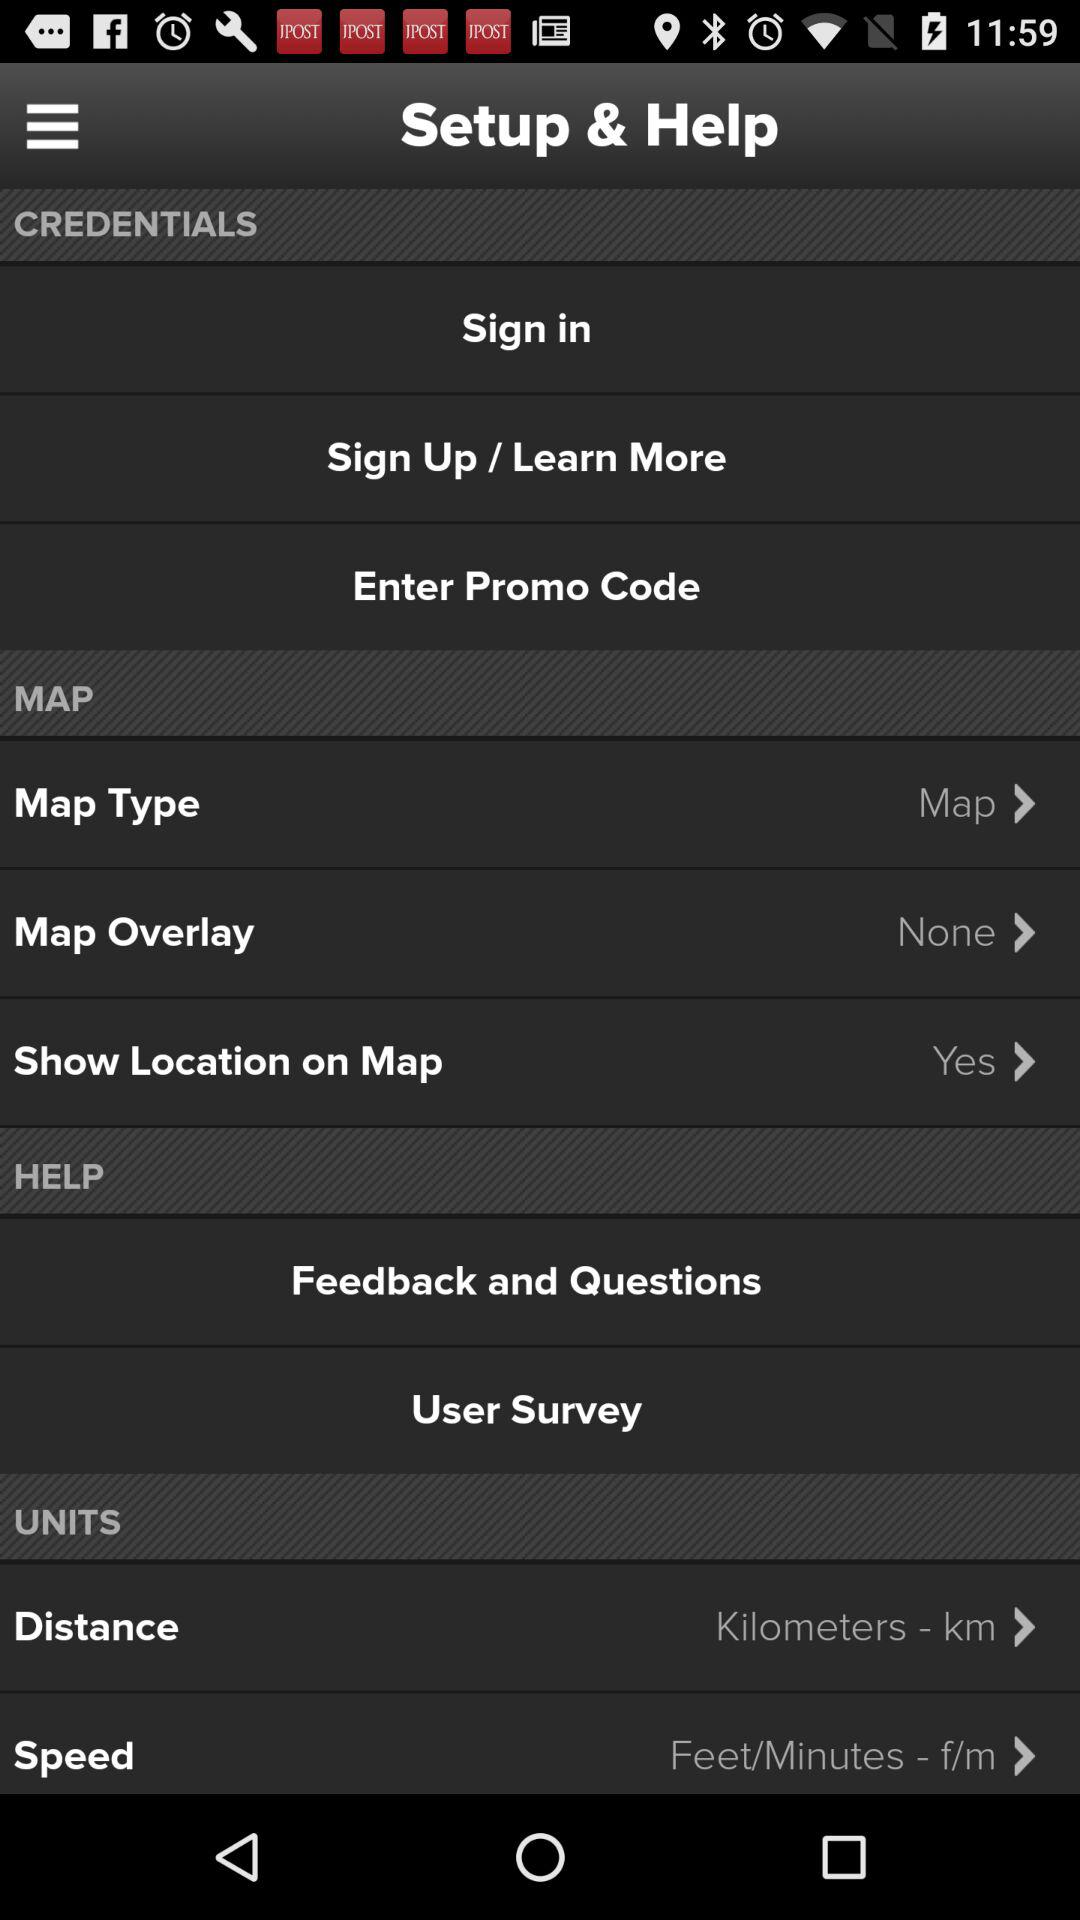What is the status of show location on map? The status is yes. 